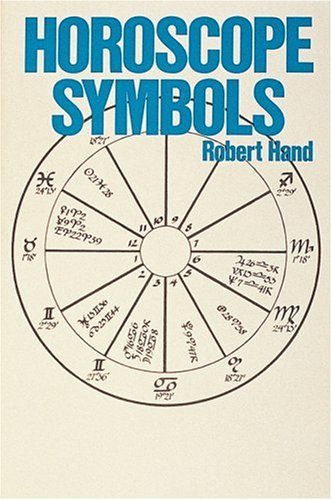Who is the author of this book?
Answer the question using a single word or phrase. Robert Hand What is the title of this book? Horoscope Symbols What type of book is this? Religion & Spirituality Is this a religious book? Yes Is this a kids book? No 